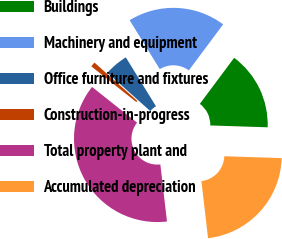Convert chart. <chart><loc_0><loc_0><loc_500><loc_500><pie_chart><fcel>Buildings<fcel>Machinery and equipment<fcel>Office furniture and fixtures<fcel>Construction-in-progress<fcel>Total property plant and<fcel>Accumulated depreciation<nl><fcel>15.32%<fcel>18.98%<fcel>4.6%<fcel>0.94%<fcel>37.52%<fcel>22.64%<nl></chart> 